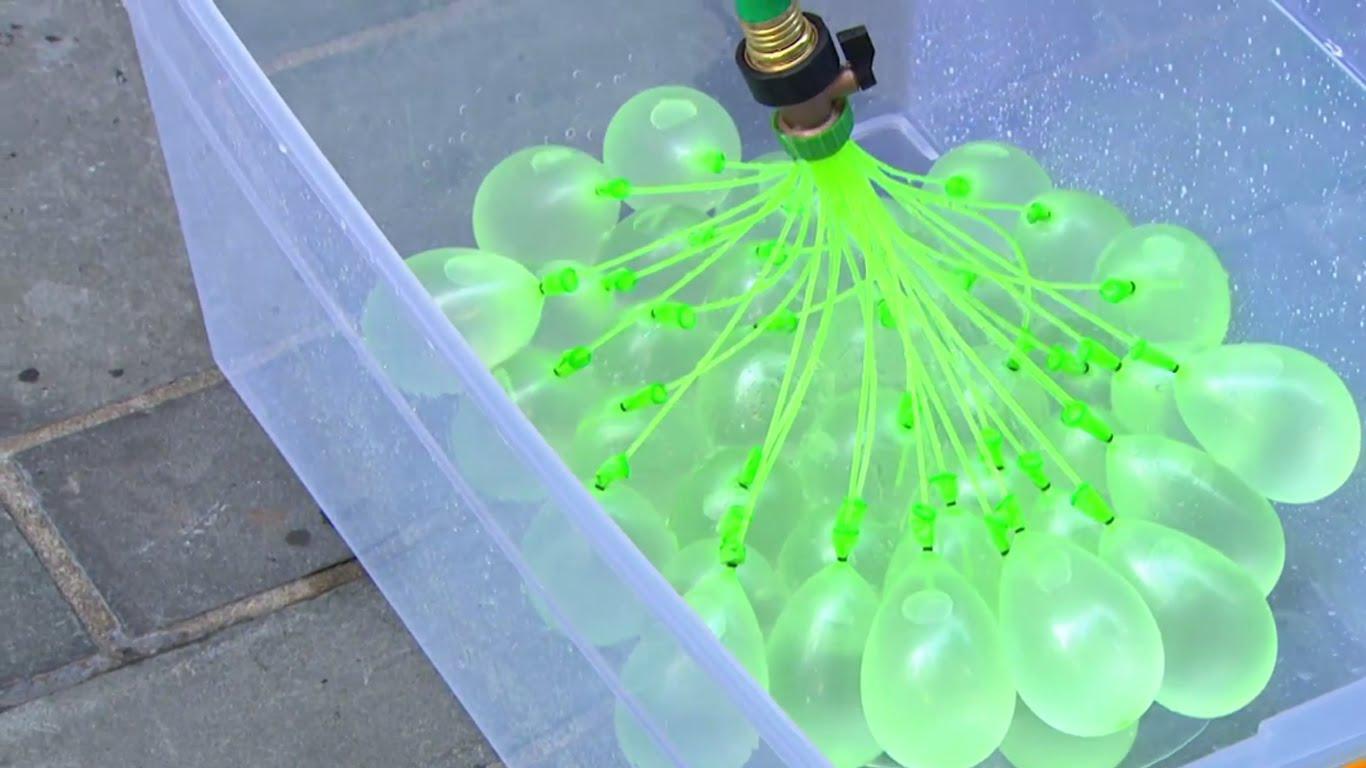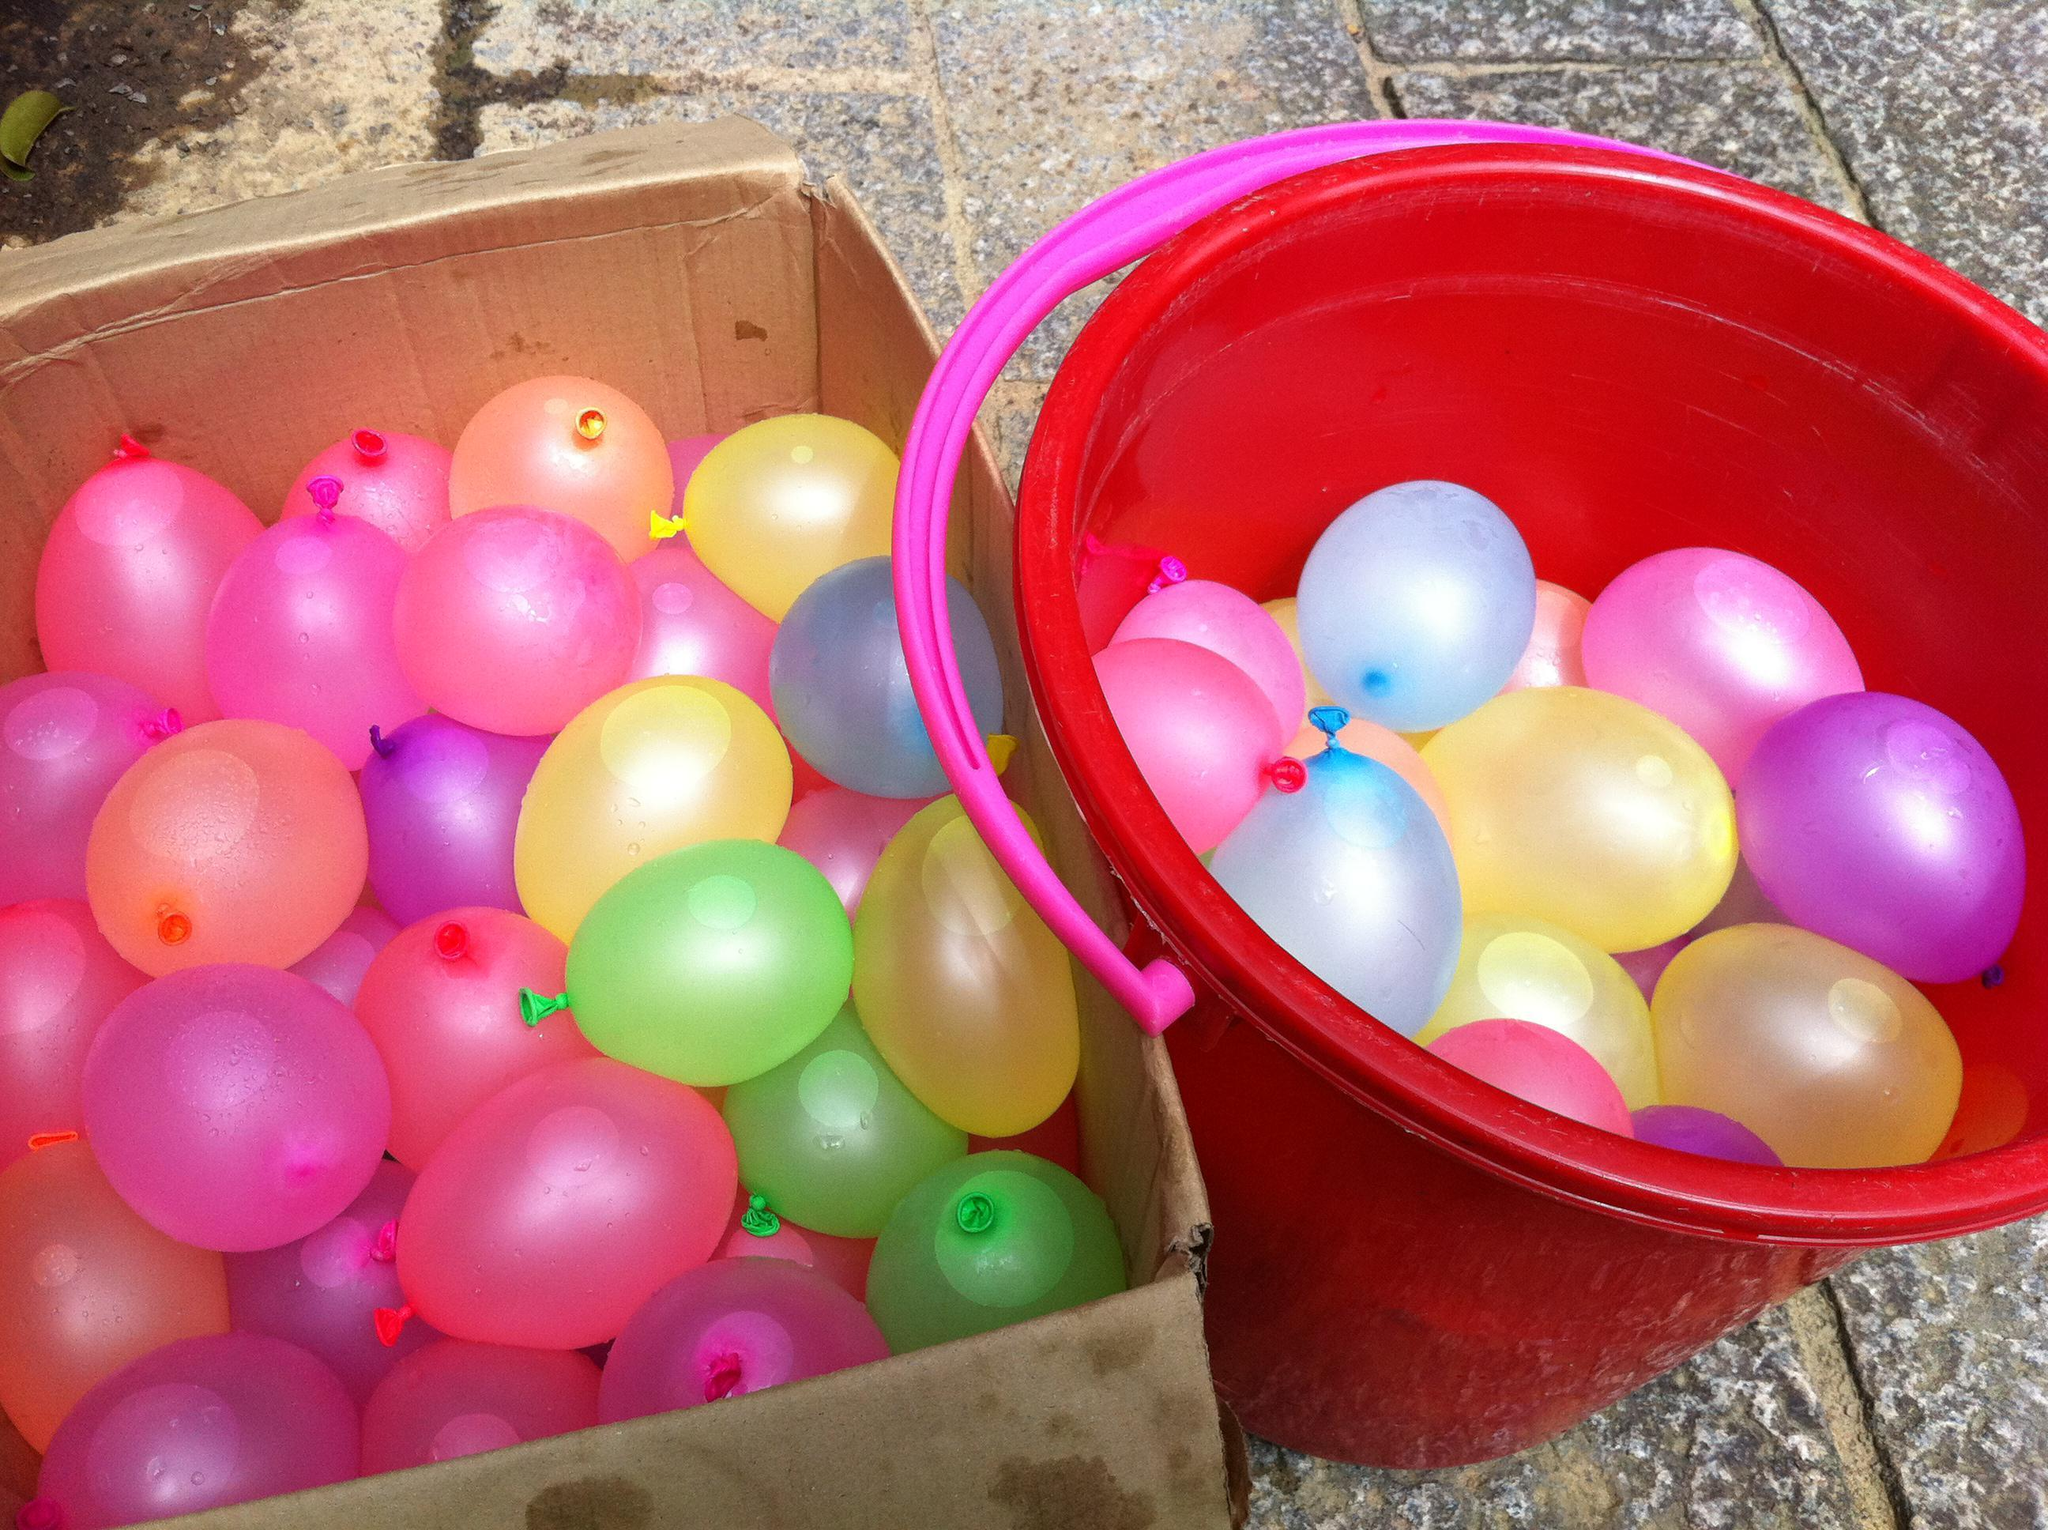The first image is the image on the left, the second image is the image on the right. For the images shown, is this caption "In at least one image there is a single balloon being filled from a water faucet." true? Answer yes or no. No. The first image is the image on the left, the second image is the image on the right. For the images shown, is this caption "A partially filled balloon is attached to a faucet." true? Answer yes or no. No. 